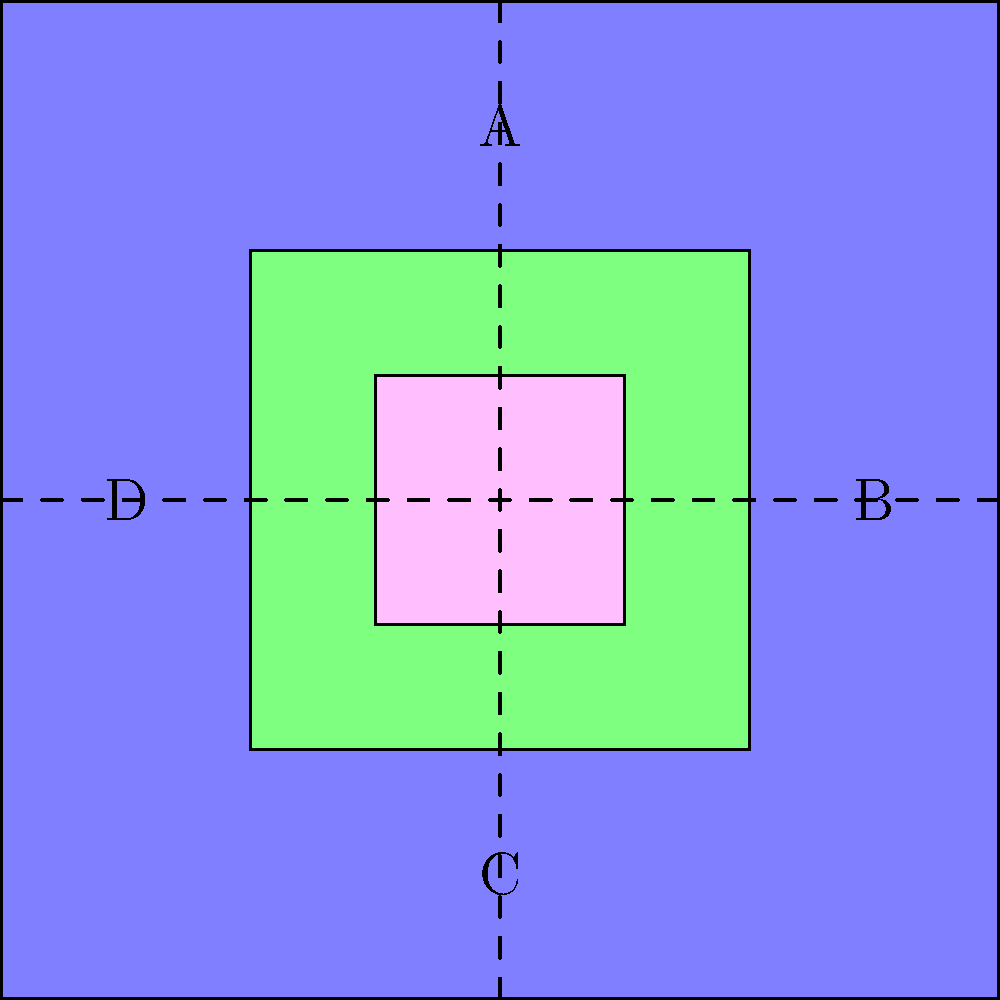In a manufacturing process flow diagram, a series of operations are represented by nested squares. The diagram undergoes a 90-degree clockwise rotation followed by a reflection across the vertical axis. What is the resulting position of point A after these transformations? Let's approach this step-by-step:

1) First, we need to understand the initial positions:
   A is at the top (12 o'clock position)
   B is at the right (3 o'clock position)
   C is at the bottom (6 o'clock position)
   D is at the left (9 o'clock position)

2) After a 90-degree clockwise rotation:
   A moves to B (3 o'clock)
   B moves to C (6 o'clock)
   C moves to D (9 o'clock)
   D moves to A (12 o'clock)

3) Now, we reflect across the vertical axis:
   The 3 o'clock position (where A is now) becomes the 9 o'clock position
   The 9 o'clock position becomes the 3 o'clock position
   The 12 o'clock and 6 o'clock positions remain unchanged

4) Therefore, after both transformations:
   A ends up in the 9 o'clock position, which was originally occupied by D

In terms of the diagram, point A has moved to the left side of the square.
Answer: Left side (D's original position) 